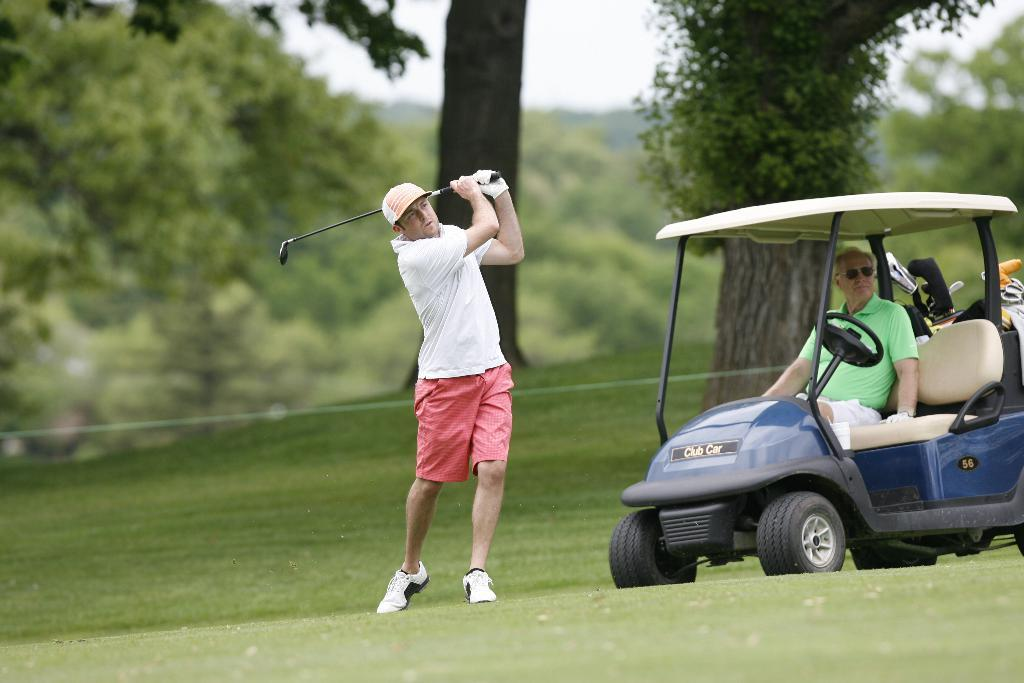What is located on the ground in the image? There is a vehicle on the ground in the image. How many people are present in the image? There are two persons in the image. What is one of the persons holding in their hands? One of the persons is holding a bat in their hands. What can be seen in the background of the image? There are trees and the sky visible in the background of the image. Can you tell me how many clovers are growing near the vehicle in the image? There is no mention of clovers in the image, so it is not possible to determine how many are present. What type of question is the person holding the bat asking in the image? There is no indication in the image that the person holding the bat is asking a question, so it cannot be determined from the image. 